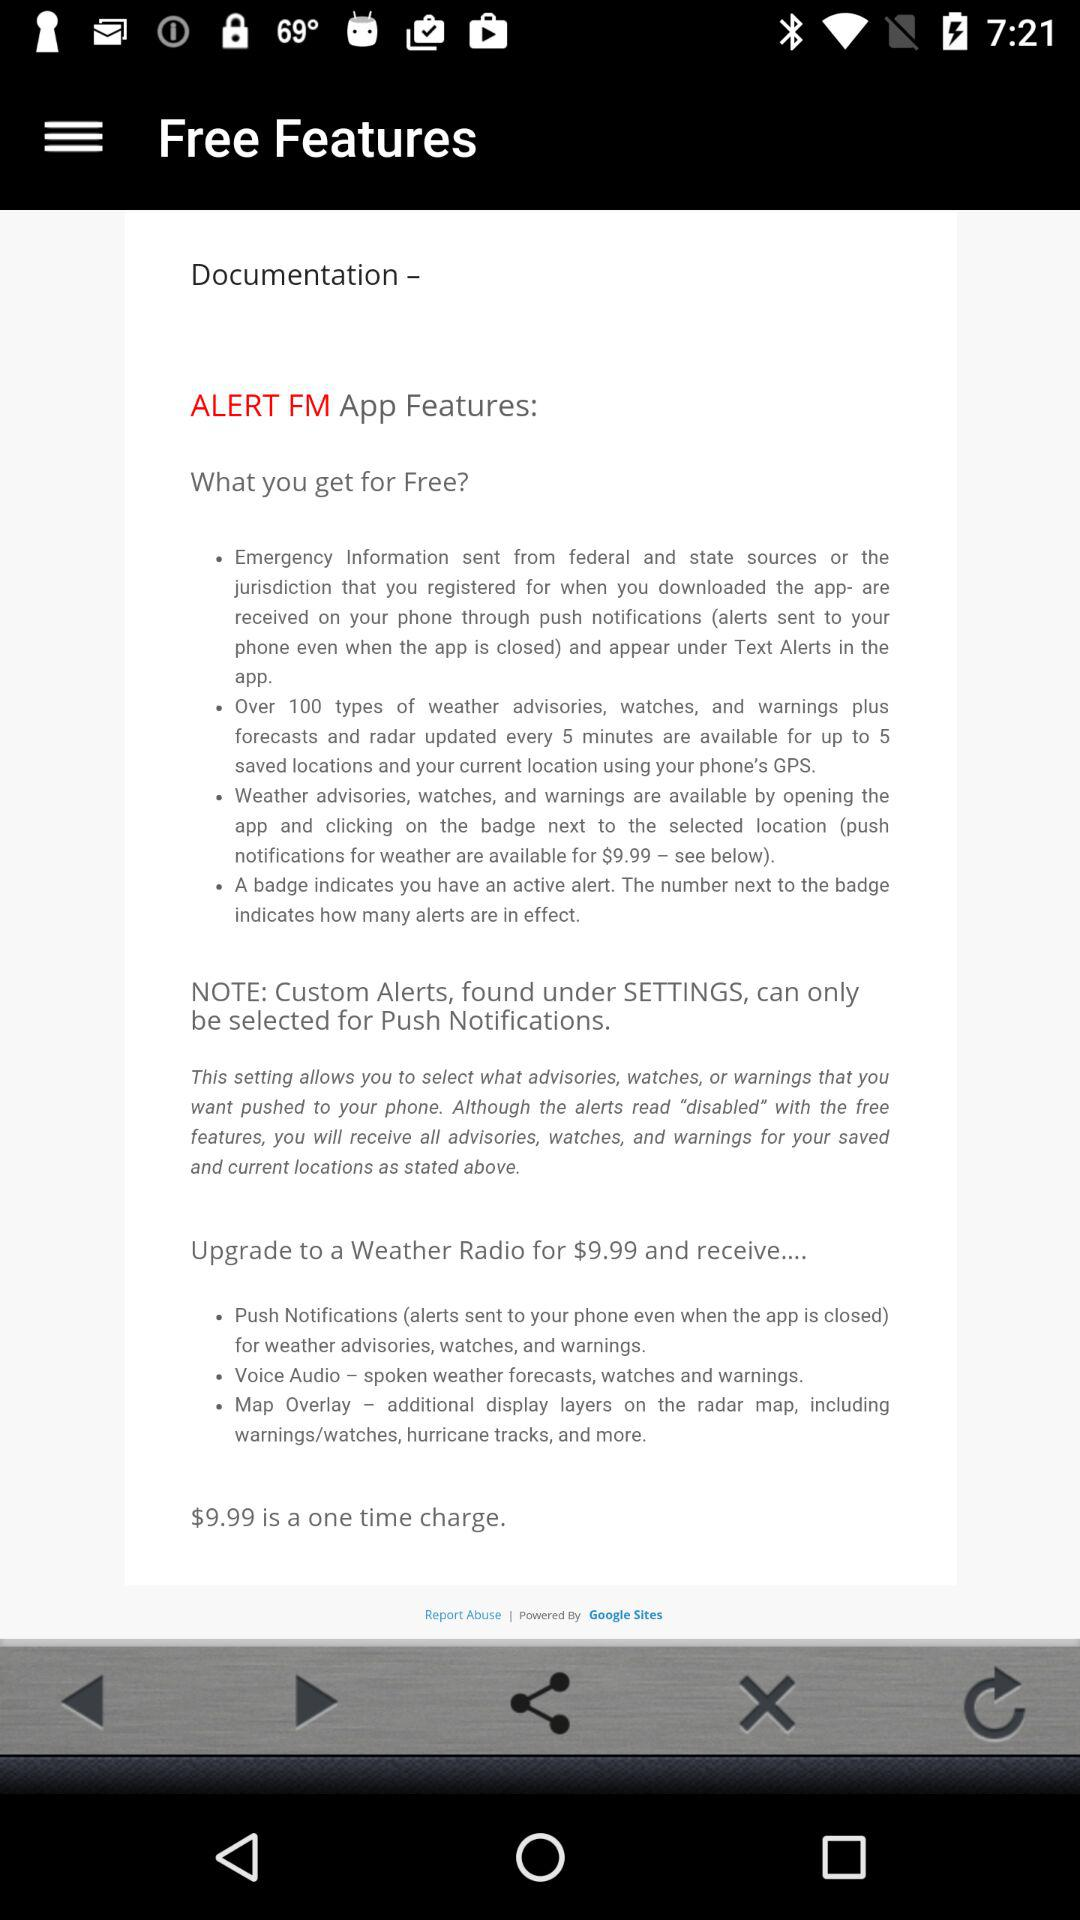How many types of weather advisories, watches, and warnings are available?
Answer the question using a single word or phrase. Over 100 